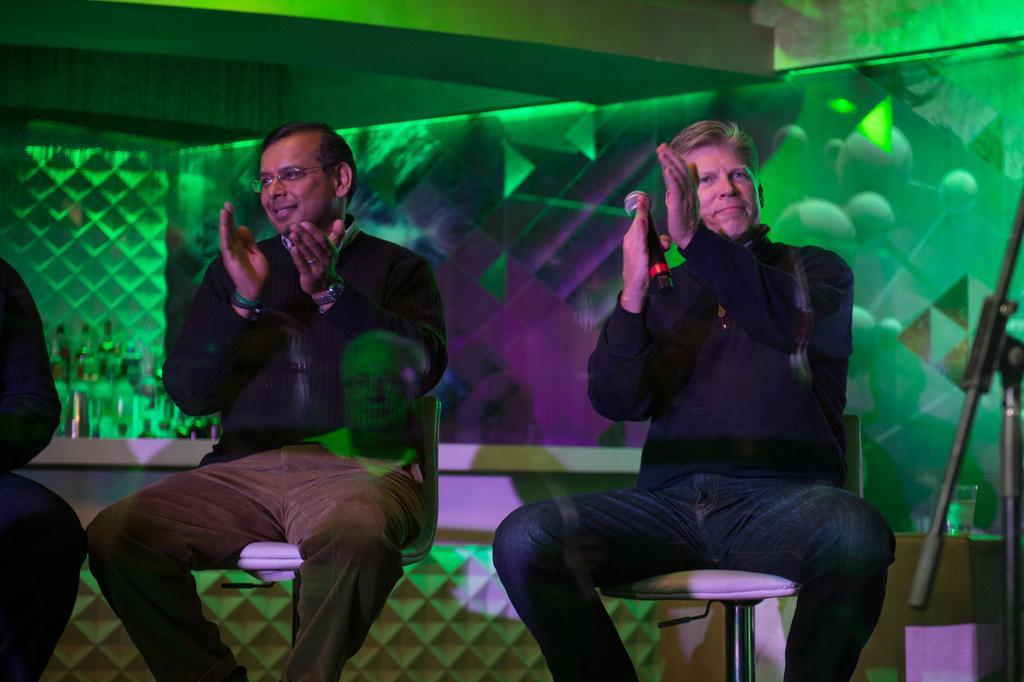Can you describe this image briefly? This picture describe about the man wearing black color jacket holding a microphone in the hand smiling and clapping the hand sitting on the white color chair. Beside we can see another man wearing a black color jacket, smiling and clapping the hand. Behind we can see a green color bar counter in some bottles placed on the left corner of the wall. 